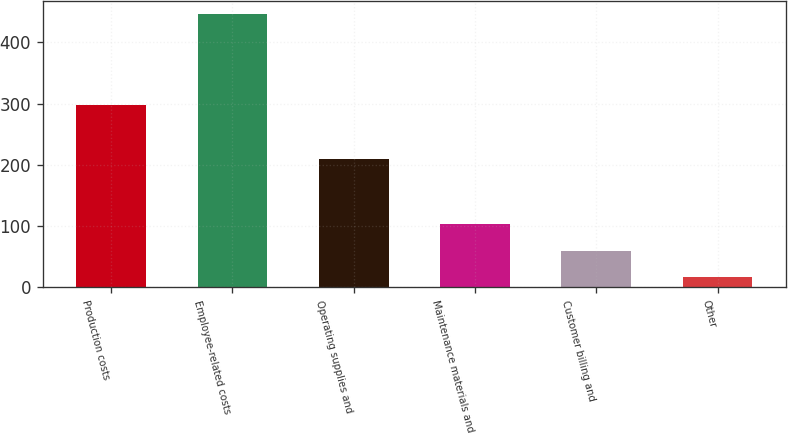<chart> <loc_0><loc_0><loc_500><loc_500><bar_chart><fcel>Production costs<fcel>Employee-related costs<fcel>Operating supplies and<fcel>Maintenance materials and<fcel>Customer billing and<fcel>Other<nl><fcel>298<fcel>446<fcel>209<fcel>102.8<fcel>59.9<fcel>17<nl></chart> 